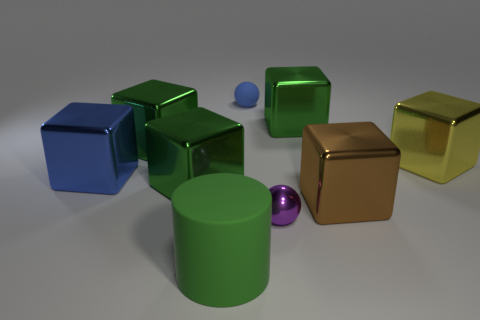What size is the blue thing that is in front of the small sphere that is behind the large blue thing?
Your answer should be very brief. Large. Is the number of large green metallic things that are on the left side of the large green cylinder less than the number of tiny purple metallic spheres?
Make the answer very short. No. The purple sphere is what size?
Provide a succinct answer. Small. What number of other small shiny objects are the same color as the small metal thing?
Offer a terse response. 0. There is a blue object behind the blue thing in front of the yellow metallic cube; are there any shiny blocks that are on the right side of it?
Make the answer very short. Yes. There is a blue thing that is the same size as the rubber cylinder; what is its shape?
Your answer should be very brief. Cube. What number of big objects are blue objects or blue cubes?
Give a very brief answer. 1. There is a tiny sphere that is made of the same material as the cylinder; what color is it?
Your answer should be very brief. Blue. Is the shape of the object that is on the right side of the large brown shiny cube the same as the rubber thing behind the cylinder?
Your response must be concise. No. How many shiny things are gray cylinders or blue cubes?
Your response must be concise. 1. 